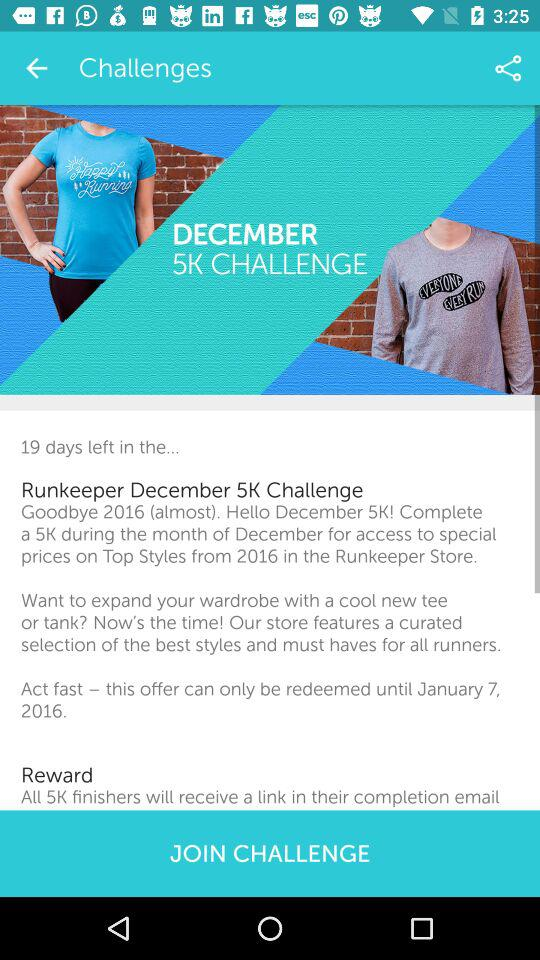What is the Runkeeper challenge? The Runkeeper challenge is to complete a 5K during the month of December. 